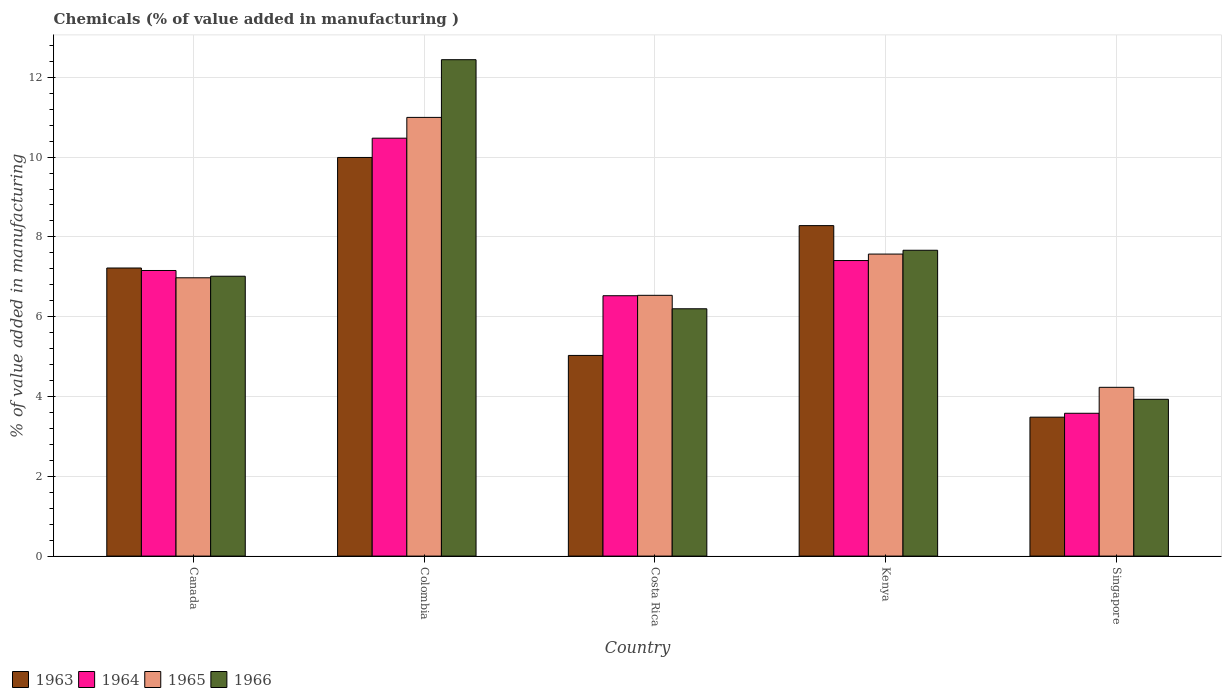How many bars are there on the 4th tick from the left?
Offer a very short reply. 4. What is the label of the 4th group of bars from the left?
Provide a succinct answer. Kenya. In how many cases, is the number of bars for a given country not equal to the number of legend labels?
Provide a succinct answer. 0. What is the value added in manufacturing chemicals in 1963 in Colombia?
Give a very brief answer. 9.99. Across all countries, what is the maximum value added in manufacturing chemicals in 1963?
Ensure brevity in your answer.  9.99. Across all countries, what is the minimum value added in manufacturing chemicals in 1964?
Make the answer very short. 3.58. In which country was the value added in manufacturing chemicals in 1964 maximum?
Make the answer very short. Colombia. In which country was the value added in manufacturing chemicals in 1965 minimum?
Make the answer very short. Singapore. What is the total value added in manufacturing chemicals in 1964 in the graph?
Your response must be concise. 35.15. What is the difference between the value added in manufacturing chemicals in 1965 in Costa Rica and that in Singapore?
Provide a short and direct response. 2.31. What is the difference between the value added in manufacturing chemicals in 1966 in Kenya and the value added in manufacturing chemicals in 1964 in Colombia?
Provide a succinct answer. -2.81. What is the average value added in manufacturing chemicals in 1964 per country?
Keep it short and to the point. 7.03. What is the difference between the value added in manufacturing chemicals of/in 1965 and value added in manufacturing chemicals of/in 1963 in Singapore?
Your answer should be compact. 0.75. What is the ratio of the value added in manufacturing chemicals in 1963 in Colombia to that in Kenya?
Keep it short and to the point. 1.21. Is the value added in manufacturing chemicals in 1965 in Costa Rica less than that in Kenya?
Provide a succinct answer. Yes. Is the difference between the value added in manufacturing chemicals in 1965 in Costa Rica and Singapore greater than the difference between the value added in manufacturing chemicals in 1963 in Costa Rica and Singapore?
Provide a short and direct response. Yes. What is the difference between the highest and the second highest value added in manufacturing chemicals in 1964?
Ensure brevity in your answer.  3.32. What is the difference between the highest and the lowest value added in manufacturing chemicals in 1964?
Provide a short and direct response. 6.89. In how many countries, is the value added in manufacturing chemicals in 1966 greater than the average value added in manufacturing chemicals in 1966 taken over all countries?
Offer a very short reply. 2. Is the sum of the value added in manufacturing chemicals in 1965 in Costa Rica and Kenya greater than the maximum value added in manufacturing chemicals in 1964 across all countries?
Ensure brevity in your answer.  Yes. Is it the case that in every country, the sum of the value added in manufacturing chemicals in 1966 and value added in manufacturing chemicals in 1965 is greater than the sum of value added in manufacturing chemicals in 1963 and value added in manufacturing chemicals in 1964?
Provide a succinct answer. No. What does the 1st bar from the left in Singapore represents?
Keep it short and to the point. 1963. How many bars are there?
Offer a terse response. 20. Are all the bars in the graph horizontal?
Your answer should be compact. No. What is the difference between two consecutive major ticks on the Y-axis?
Provide a succinct answer. 2. Does the graph contain any zero values?
Provide a short and direct response. No. Does the graph contain grids?
Ensure brevity in your answer.  Yes. How are the legend labels stacked?
Provide a short and direct response. Horizontal. What is the title of the graph?
Your answer should be very brief. Chemicals (% of value added in manufacturing ). What is the label or title of the X-axis?
Ensure brevity in your answer.  Country. What is the label or title of the Y-axis?
Make the answer very short. % of value added in manufacturing. What is the % of value added in manufacturing of 1963 in Canada?
Your answer should be compact. 7.22. What is the % of value added in manufacturing of 1964 in Canada?
Offer a terse response. 7.16. What is the % of value added in manufacturing of 1965 in Canada?
Keep it short and to the point. 6.98. What is the % of value added in manufacturing of 1966 in Canada?
Make the answer very short. 7.01. What is the % of value added in manufacturing of 1963 in Colombia?
Keep it short and to the point. 9.99. What is the % of value added in manufacturing of 1964 in Colombia?
Provide a short and direct response. 10.47. What is the % of value added in manufacturing in 1965 in Colombia?
Your response must be concise. 10.99. What is the % of value added in manufacturing of 1966 in Colombia?
Give a very brief answer. 12.44. What is the % of value added in manufacturing of 1963 in Costa Rica?
Keep it short and to the point. 5.03. What is the % of value added in manufacturing of 1964 in Costa Rica?
Offer a terse response. 6.53. What is the % of value added in manufacturing of 1965 in Costa Rica?
Make the answer very short. 6.54. What is the % of value added in manufacturing in 1966 in Costa Rica?
Give a very brief answer. 6.2. What is the % of value added in manufacturing of 1963 in Kenya?
Keep it short and to the point. 8.28. What is the % of value added in manufacturing of 1964 in Kenya?
Your answer should be compact. 7.41. What is the % of value added in manufacturing of 1965 in Kenya?
Offer a terse response. 7.57. What is the % of value added in manufacturing of 1966 in Kenya?
Offer a very short reply. 7.67. What is the % of value added in manufacturing of 1963 in Singapore?
Your response must be concise. 3.48. What is the % of value added in manufacturing in 1964 in Singapore?
Offer a terse response. 3.58. What is the % of value added in manufacturing of 1965 in Singapore?
Provide a succinct answer. 4.23. What is the % of value added in manufacturing in 1966 in Singapore?
Ensure brevity in your answer.  3.93. Across all countries, what is the maximum % of value added in manufacturing of 1963?
Make the answer very short. 9.99. Across all countries, what is the maximum % of value added in manufacturing of 1964?
Offer a very short reply. 10.47. Across all countries, what is the maximum % of value added in manufacturing of 1965?
Give a very brief answer. 10.99. Across all countries, what is the maximum % of value added in manufacturing in 1966?
Keep it short and to the point. 12.44. Across all countries, what is the minimum % of value added in manufacturing of 1963?
Your response must be concise. 3.48. Across all countries, what is the minimum % of value added in manufacturing in 1964?
Make the answer very short. 3.58. Across all countries, what is the minimum % of value added in manufacturing in 1965?
Offer a very short reply. 4.23. Across all countries, what is the minimum % of value added in manufacturing of 1966?
Offer a very short reply. 3.93. What is the total % of value added in manufacturing in 1963 in the graph?
Your answer should be compact. 34.01. What is the total % of value added in manufacturing of 1964 in the graph?
Ensure brevity in your answer.  35.15. What is the total % of value added in manufacturing of 1965 in the graph?
Your answer should be compact. 36.31. What is the total % of value added in manufacturing of 1966 in the graph?
Offer a terse response. 37.25. What is the difference between the % of value added in manufacturing of 1963 in Canada and that in Colombia?
Offer a very short reply. -2.77. What is the difference between the % of value added in manufacturing in 1964 in Canada and that in Colombia?
Make the answer very short. -3.32. What is the difference between the % of value added in manufacturing in 1965 in Canada and that in Colombia?
Offer a terse response. -4.02. What is the difference between the % of value added in manufacturing of 1966 in Canada and that in Colombia?
Provide a succinct answer. -5.43. What is the difference between the % of value added in manufacturing in 1963 in Canada and that in Costa Rica?
Make the answer very short. 2.19. What is the difference between the % of value added in manufacturing in 1964 in Canada and that in Costa Rica?
Offer a very short reply. 0.63. What is the difference between the % of value added in manufacturing in 1965 in Canada and that in Costa Rica?
Offer a very short reply. 0.44. What is the difference between the % of value added in manufacturing of 1966 in Canada and that in Costa Rica?
Offer a very short reply. 0.82. What is the difference between the % of value added in manufacturing in 1963 in Canada and that in Kenya?
Your response must be concise. -1.06. What is the difference between the % of value added in manufacturing of 1964 in Canada and that in Kenya?
Ensure brevity in your answer.  -0.25. What is the difference between the % of value added in manufacturing of 1965 in Canada and that in Kenya?
Ensure brevity in your answer.  -0.59. What is the difference between the % of value added in manufacturing in 1966 in Canada and that in Kenya?
Your answer should be very brief. -0.65. What is the difference between the % of value added in manufacturing in 1963 in Canada and that in Singapore?
Your answer should be very brief. 3.74. What is the difference between the % of value added in manufacturing in 1964 in Canada and that in Singapore?
Give a very brief answer. 3.58. What is the difference between the % of value added in manufacturing of 1965 in Canada and that in Singapore?
Your answer should be very brief. 2.75. What is the difference between the % of value added in manufacturing in 1966 in Canada and that in Singapore?
Provide a short and direct response. 3.08. What is the difference between the % of value added in manufacturing in 1963 in Colombia and that in Costa Rica?
Offer a very short reply. 4.96. What is the difference between the % of value added in manufacturing in 1964 in Colombia and that in Costa Rica?
Give a very brief answer. 3.95. What is the difference between the % of value added in manufacturing in 1965 in Colombia and that in Costa Rica?
Make the answer very short. 4.46. What is the difference between the % of value added in manufacturing of 1966 in Colombia and that in Costa Rica?
Make the answer very short. 6.24. What is the difference between the % of value added in manufacturing in 1963 in Colombia and that in Kenya?
Your answer should be very brief. 1.71. What is the difference between the % of value added in manufacturing of 1964 in Colombia and that in Kenya?
Your response must be concise. 3.07. What is the difference between the % of value added in manufacturing of 1965 in Colombia and that in Kenya?
Your response must be concise. 3.43. What is the difference between the % of value added in manufacturing in 1966 in Colombia and that in Kenya?
Your answer should be compact. 4.78. What is the difference between the % of value added in manufacturing in 1963 in Colombia and that in Singapore?
Make the answer very short. 6.51. What is the difference between the % of value added in manufacturing of 1964 in Colombia and that in Singapore?
Your answer should be very brief. 6.89. What is the difference between the % of value added in manufacturing in 1965 in Colombia and that in Singapore?
Your answer should be very brief. 6.76. What is the difference between the % of value added in manufacturing in 1966 in Colombia and that in Singapore?
Your answer should be compact. 8.51. What is the difference between the % of value added in manufacturing in 1963 in Costa Rica and that in Kenya?
Offer a very short reply. -3.25. What is the difference between the % of value added in manufacturing of 1964 in Costa Rica and that in Kenya?
Your response must be concise. -0.88. What is the difference between the % of value added in manufacturing in 1965 in Costa Rica and that in Kenya?
Give a very brief answer. -1.03. What is the difference between the % of value added in manufacturing in 1966 in Costa Rica and that in Kenya?
Your answer should be very brief. -1.47. What is the difference between the % of value added in manufacturing in 1963 in Costa Rica and that in Singapore?
Keep it short and to the point. 1.55. What is the difference between the % of value added in manufacturing of 1964 in Costa Rica and that in Singapore?
Your response must be concise. 2.95. What is the difference between the % of value added in manufacturing of 1965 in Costa Rica and that in Singapore?
Give a very brief answer. 2.31. What is the difference between the % of value added in manufacturing of 1966 in Costa Rica and that in Singapore?
Provide a succinct answer. 2.27. What is the difference between the % of value added in manufacturing in 1963 in Kenya and that in Singapore?
Offer a very short reply. 4.8. What is the difference between the % of value added in manufacturing in 1964 in Kenya and that in Singapore?
Your answer should be very brief. 3.83. What is the difference between the % of value added in manufacturing in 1965 in Kenya and that in Singapore?
Provide a succinct answer. 3.34. What is the difference between the % of value added in manufacturing of 1966 in Kenya and that in Singapore?
Your answer should be very brief. 3.74. What is the difference between the % of value added in manufacturing of 1963 in Canada and the % of value added in manufacturing of 1964 in Colombia?
Your answer should be compact. -3.25. What is the difference between the % of value added in manufacturing in 1963 in Canada and the % of value added in manufacturing in 1965 in Colombia?
Provide a succinct answer. -3.77. What is the difference between the % of value added in manufacturing in 1963 in Canada and the % of value added in manufacturing in 1966 in Colombia?
Provide a short and direct response. -5.22. What is the difference between the % of value added in manufacturing of 1964 in Canada and the % of value added in manufacturing of 1965 in Colombia?
Give a very brief answer. -3.84. What is the difference between the % of value added in manufacturing of 1964 in Canada and the % of value added in manufacturing of 1966 in Colombia?
Give a very brief answer. -5.28. What is the difference between the % of value added in manufacturing in 1965 in Canada and the % of value added in manufacturing in 1966 in Colombia?
Provide a short and direct response. -5.47. What is the difference between the % of value added in manufacturing of 1963 in Canada and the % of value added in manufacturing of 1964 in Costa Rica?
Provide a succinct answer. 0.69. What is the difference between the % of value added in manufacturing of 1963 in Canada and the % of value added in manufacturing of 1965 in Costa Rica?
Your answer should be very brief. 0.68. What is the difference between the % of value added in manufacturing in 1963 in Canada and the % of value added in manufacturing in 1966 in Costa Rica?
Make the answer very short. 1.02. What is the difference between the % of value added in manufacturing of 1964 in Canada and the % of value added in manufacturing of 1965 in Costa Rica?
Give a very brief answer. 0.62. What is the difference between the % of value added in manufacturing of 1964 in Canada and the % of value added in manufacturing of 1966 in Costa Rica?
Ensure brevity in your answer.  0.96. What is the difference between the % of value added in manufacturing in 1965 in Canada and the % of value added in manufacturing in 1966 in Costa Rica?
Ensure brevity in your answer.  0.78. What is the difference between the % of value added in manufacturing in 1963 in Canada and the % of value added in manufacturing in 1964 in Kenya?
Your answer should be very brief. -0.19. What is the difference between the % of value added in manufacturing of 1963 in Canada and the % of value added in manufacturing of 1965 in Kenya?
Keep it short and to the point. -0.35. What is the difference between the % of value added in manufacturing in 1963 in Canada and the % of value added in manufacturing in 1966 in Kenya?
Offer a very short reply. -0.44. What is the difference between the % of value added in manufacturing in 1964 in Canada and the % of value added in manufacturing in 1965 in Kenya?
Provide a succinct answer. -0.41. What is the difference between the % of value added in manufacturing of 1964 in Canada and the % of value added in manufacturing of 1966 in Kenya?
Your response must be concise. -0.51. What is the difference between the % of value added in manufacturing of 1965 in Canada and the % of value added in manufacturing of 1966 in Kenya?
Offer a terse response. -0.69. What is the difference between the % of value added in manufacturing in 1963 in Canada and the % of value added in manufacturing in 1964 in Singapore?
Make the answer very short. 3.64. What is the difference between the % of value added in manufacturing of 1963 in Canada and the % of value added in manufacturing of 1965 in Singapore?
Provide a succinct answer. 2.99. What is the difference between the % of value added in manufacturing in 1963 in Canada and the % of value added in manufacturing in 1966 in Singapore?
Provide a short and direct response. 3.29. What is the difference between the % of value added in manufacturing of 1964 in Canada and the % of value added in manufacturing of 1965 in Singapore?
Your response must be concise. 2.93. What is the difference between the % of value added in manufacturing in 1964 in Canada and the % of value added in manufacturing in 1966 in Singapore?
Ensure brevity in your answer.  3.23. What is the difference between the % of value added in manufacturing in 1965 in Canada and the % of value added in manufacturing in 1966 in Singapore?
Keep it short and to the point. 3.05. What is the difference between the % of value added in manufacturing of 1963 in Colombia and the % of value added in manufacturing of 1964 in Costa Rica?
Give a very brief answer. 3.47. What is the difference between the % of value added in manufacturing of 1963 in Colombia and the % of value added in manufacturing of 1965 in Costa Rica?
Your response must be concise. 3.46. What is the difference between the % of value added in manufacturing of 1963 in Colombia and the % of value added in manufacturing of 1966 in Costa Rica?
Your response must be concise. 3.79. What is the difference between the % of value added in manufacturing in 1964 in Colombia and the % of value added in manufacturing in 1965 in Costa Rica?
Make the answer very short. 3.94. What is the difference between the % of value added in manufacturing in 1964 in Colombia and the % of value added in manufacturing in 1966 in Costa Rica?
Offer a terse response. 4.28. What is the difference between the % of value added in manufacturing of 1965 in Colombia and the % of value added in manufacturing of 1966 in Costa Rica?
Provide a succinct answer. 4.8. What is the difference between the % of value added in manufacturing in 1963 in Colombia and the % of value added in manufacturing in 1964 in Kenya?
Your answer should be very brief. 2.58. What is the difference between the % of value added in manufacturing in 1963 in Colombia and the % of value added in manufacturing in 1965 in Kenya?
Provide a succinct answer. 2.42. What is the difference between the % of value added in manufacturing of 1963 in Colombia and the % of value added in manufacturing of 1966 in Kenya?
Offer a very short reply. 2.33. What is the difference between the % of value added in manufacturing in 1964 in Colombia and the % of value added in manufacturing in 1965 in Kenya?
Give a very brief answer. 2.9. What is the difference between the % of value added in manufacturing of 1964 in Colombia and the % of value added in manufacturing of 1966 in Kenya?
Your response must be concise. 2.81. What is the difference between the % of value added in manufacturing of 1965 in Colombia and the % of value added in manufacturing of 1966 in Kenya?
Your response must be concise. 3.33. What is the difference between the % of value added in manufacturing of 1963 in Colombia and the % of value added in manufacturing of 1964 in Singapore?
Offer a terse response. 6.41. What is the difference between the % of value added in manufacturing in 1963 in Colombia and the % of value added in manufacturing in 1965 in Singapore?
Your answer should be compact. 5.76. What is the difference between the % of value added in manufacturing of 1963 in Colombia and the % of value added in manufacturing of 1966 in Singapore?
Your response must be concise. 6.06. What is the difference between the % of value added in manufacturing in 1964 in Colombia and the % of value added in manufacturing in 1965 in Singapore?
Give a very brief answer. 6.24. What is the difference between the % of value added in manufacturing of 1964 in Colombia and the % of value added in manufacturing of 1966 in Singapore?
Your answer should be compact. 6.54. What is the difference between the % of value added in manufacturing of 1965 in Colombia and the % of value added in manufacturing of 1966 in Singapore?
Provide a succinct answer. 7.07. What is the difference between the % of value added in manufacturing in 1963 in Costa Rica and the % of value added in manufacturing in 1964 in Kenya?
Make the answer very short. -2.38. What is the difference between the % of value added in manufacturing of 1963 in Costa Rica and the % of value added in manufacturing of 1965 in Kenya?
Your response must be concise. -2.54. What is the difference between the % of value added in manufacturing of 1963 in Costa Rica and the % of value added in manufacturing of 1966 in Kenya?
Your answer should be very brief. -2.64. What is the difference between the % of value added in manufacturing in 1964 in Costa Rica and the % of value added in manufacturing in 1965 in Kenya?
Offer a very short reply. -1.04. What is the difference between the % of value added in manufacturing of 1964 in Costa Rica and the % of value added in manufacturing of 1966 in Kenya?
Provide a short and direct response. -1.14. What is the difference between the % of value added in manufacturing in 1965 in Costa Rica and the % of value added in manufacturing in 1966 in Kenya?
Keep it short and to the point. -1.13. What is the difference between the % of value added in manufacturing of 1963 in Costa Rica and the % of value added in manufacturing of 1964 in Singapore?
Ensure brevity in your answer.  1.45. What is the difference between the % of value added in manufacturing in 1963 in Costa Rica and the % of value added in manufacturing in 1965 in Singapore?
Offer a very short reply. 0.8. What is the difference between the % of value added in manufacturing of 1963 in Costa Rica and the % of value added in manufacturing of 1966 in Singapore?
Provide a succinct answer. 1.1. What is the difference between the % of value added in manufacturing in 1964 in Costa Rica and the % of value added in manufacturing in 1965 in Singapore?
Offer a terse response. 2.3. What is the difference between the % of value added in manufacturing of 1964 in Costa Rica and the % of value added in manufacturing of 1966 in Singapore?
Ensure brevity in your answer.  2.6. What is the difference between the % of value added in manufacturing in 1965 in Costa Rica and the % of value added in manufacturing in 1966 in Singapore?
Your response must be concise. 2.61. What is the difference between the % of value added in manufacturing in 1963 in Kenya and the % of value added in manufacturing in 1964 in Singapore?
Provide a succinct answer. 4.7. What is the difference between the % of value added in manufacturing of 1963 in Kenya and the % of value added in manufacturing of 1965 in Singapore?
Your answer should be compact. 4.05. What is the difference between the % of value added in manufacturing in 1963 in Kenya and the % of value added in manufacturing in 1966 in Singapore?
Your answer should be very brief. 4.35. What is the difference between the % of value added in manufacturing of 1964 in Kenya and the % of value added in manufacturing of 1965 in Singapore?
Offer a terse response. 3.18. What is the difference between the % of value added in manufacturing of 1964 in Kenya and the % of value added in manufacturing of 1966 in Singapore?
Give a very brief answer. 3.48. What is the difference between the % of value added in manufacturing in 1965 in Kenya and the % of value added in manufacturing in 1966 in Singapore?
Offer a very short reply. 3.64. What is the average % of value added in manufacturing of 1963 per country?
Provide a short and direct response. 6.8. What is the average % of value added in manufacturing of 1964 per country?
Offer a terse response. 7.03. What is the average % of value added in manufacturing of 1965 per country?
Provide a short and direct response. 7.26. What is the average % of value added in manufacturing in 1966 per country?
Ensure brevity in your answer.  7.45. What is the difference between the % of value added in manufacturing of 1963 and % of value added in manufacturing of 1964 in Canada?
Offer a very short reply. 0.06. What is the difference between the % of value added in manufacturing of 1963 and % of value added in manufacturing of 1965 in Canada?
Your response must be concise. 0.25. What is the difference between the % of value added in manufacturing of 1963 and % of value added in manufacturing of 1966 in Canada?
Offer a very short reply. 0.21. What is the difference between the % of value added in manufacturing of 1964 and % of value added in manufacturing of 1965 in Canada?
Make the answer very short. 0.18. What is the difference between the % of value added in manufacturing of 1964 and % of value added in manufacturing of 1966 in Canada?
Provide a succinct answer. 0.14. What is the difference between the % of value added in manufacturing of 1965 and % of value added in manufacturing of 1966 in Canada?
Offer a terse response. -0.04. What is the difference between the % of value added in manufacturing in 1963 and % of value added in manufacturing in 1964 in Colombia?
Provide a succinct answer. -0.48. What is the difference between the % of value added in manufacturing in 1963 and % of value added in manufacturing in 1965 in Colombia?
Keep it short and to the point. -1. What is the difference between the % of value added in manufacturing in 1963 and % of value added in manufacturing in 1966 in Colombia?
Offer a very short reply. -2.45. What is the difference between the % of value added in manufacturing of 1964 and % of value added in manufacturing of 1965 in Colombia?
Your answer should be very brief. -0.52. What is the difference between the % of value added in manufacturing of 1964 and % of value added in manufacturing of 1966 in Colombia?
Make the answer very short. -1.97. What is the difference between the % of value added in manufacturing of 1965 and % of value added in manufacturing of 1966 in Colombia?
Provide a succinct answer. -1.45. What is the difference between the % of value added in manufacturing in 1963 and % of value added in manufacturing in 1964 in Costa Rica?
Provide a succinct answer. -1.5. What is the difference between the % of value added in manufacturing of 1963 and % of value added in manufacturing of 1965 in Costa Rica?
Offer a terse response. -1.51. What is the difference between the % of value added in manufacturing in 1963 and % of value added in manufacturing in 1966 in Costa Rica?
Keep it short and to the point. -1.17. What is the difference between the % of value added in manufacturing of 1964 and % of value added in manufacturing of 1965 in Costa Rica?
Keep it short and to the point. -0.01. What is the difference between the % of value added in manufacturing of 1964 and % of value added in manufacturing of 1966 in Costa Rica?
Your answer should be compact. 0.33. What is the difference between the % of value added in manufacturing in 1965 and % of value added in manufacturing in 1966 in Costa Rica?
Make the answer very short. 0.34. What is the difference between the % of value added in manufacturing of 1963 and % of value added in manufacturing of 1964 in Kenya?
Keep it short and to the point. 0.87. What is the difference between the % of value added in manufacturing in 1963 and % of value added in manufacturing in 1965 in Kenya?
Ensure brevity in your answer.  0.71. What is the difference between the % of value added in manufacturing of 1963 and % of value added in manufacturing of 1966 in Kenya?
Your response must be concise. 0.62. What is the difference between the % of value added in manufacturing of 1964 and % of value added in manufacturing of 1965 in Kenya?
Your response must be concise. -0.16. What is the difference between the % of value added in manufacturing of 1964 and % of value added in manufacturing of 1966 in Kenya?
Offer a very short reply. -0.26. What is the difference between the % of value added in manufacturing in 1965 and % of value added in manufacturing in 1966 in Kenya?
Offer a terse response. -0.1. What is the difference between the % of value added in manufacturing of 1963 and % of value added in manufacturing of 1964 in Singapore?
Ensure brevity in your answer.  -0.1. What is the difference between the % of value added in manufacturing in 1963 and % of value added in manufacturing in 1965 in Singapore?
Your answer should be very brief. -0.75. What is the difference between the % of value added in manufacturing in 1963 and % of value added in manufacturing in 1966 in Singapore?
Provide a succinct answer. -0.45. What is the difference between the % of value added in manufacturing of 1964 and % of value added in manufacturing of 1965 in Singapore?
Your answer should be very brief. -0.65. What is the difference between the % of value added in manufacturing in 1964 and % of value added in manufacturing in 1966 in Singapore?
Your answer should be compact. -0.35. What is the difference between the % of value added in manufacturing of 1965 and % of value added in manufacturing of 1966 in Singapore?
Give a very brief answer. 0.3. What is the ratio of the % of value added in manufacturing of 1963 in Canada to that in Colombia?
Make the answer very short. 0.72. What is the ratio of the % of value added in manufacturing in 1964 in Canada to that in Colombia?
Provide a succinct answer. 0.68. What is the ratio of the % of value added in manufacturing in 1965 in Canada to that in Colombia?
Your answer should be very brief. 0.63. What is the ratio of the % of value added in manufacturing in 1966 in Canada to that in Colombia?
Your answer should be compact. 0.56. What is the ratio of the % of value added in manufacturing in 1963 in Canada to that in Costa Rica?
Keep it short and to the point. 1.44. What is the ratio of the % of value added in manufacturing in 1964 in Canada to that in Costa Rica?
Your answer should be very brief. 1.1. What is the ratio of the % of value added in manufacturing of 1965 in Canada to that in Costa Rica?
Give a very brief answer. 1.07. What is the ratio of the % of value added in manufacturing of 1966 in Canada to that in Costa Rica?
Your answer should be compact. 1.13. What is the ratio of the % of value added in manufacturing in 1963 in Canada to that in Kenya?
Make the answer very short. 0.87. What is the ratio of the % of value added in manufacturing in 1964 in Canada to that in Kenya?
Offer a very short reply. 0.97. What is the ratio of the % of value added in manufacturing of 1965 in Canada to that in Kenya?
Offer a terse response. 0.92. What is the ratio of the % of value added in manufacturing in 1966 in Canada to that in Kenya?
Ensure brevity in your answer.  0.92. What is the ratio of the % of value added in manufacturing in 1963 in Canada to that in Singapore?
Keep it short and to the point. 2.07. What is the ratio of the % of value added in manufacturing of 1964 in Canada to that in Singapore?
Offer a terse response. 2. What is the ratio of the % of value added in manufacturing of 1965 in Canada to that in Singapore?
Keep it short and to the point. 1.65. What is the ratio of the % of value added in manufacturing in 1966 in Canada to that in Singapore?
Give a very brief answer. 1.78. What is the ratio of the % of value added in manufacturing in 1963 in Colombia to that in Costa Rica?
Your answer should be very brief. 1.99. What is the ratio of the % of value added in manufacturing in 1964 in Colombia to that in Costa Rica?
Keep it short and to the point. 1.61. What is the ratio of the % of value added in manufacturing in 1965 in Colombia to that in Costa Rica?
Keep it short and to the point. 1.68. What is the ratio of the % of value added in manufacturing in 1966 in Colombia to that in Costa Rica?
Your answer should be compact. 2.01. What is the ratio of the % of value added in manufacturing in 1963 in Colombia to that in Kenya?
Keep it short and to the point. 1.21. What is the ratio of the % of value added in manufacturing in 1964 in Colombia to that in Kenya?
Ensure brevity in your answer.  1.41. What is the ratio of the % of value added in manufacturing of 1965 in Colombia to that in Kenya?
Make the answer very short. 1.45. What is the ratio of the % of value added in manufacturing in 1966 in Colombia to that in Kenya?
Keep it short and to the point. 1.62. What is the ratio of the % of value added in manufacturing in 1963 in Colombia to that in Singapore?
Provide a short and direct response. 2.87. What is the ratio of the % of value added in manufacturing in 1964 in Colombia to that in Singapore?
Make the answer very short. 2.93. What is the ratio of the % of value added in manufacturing in 1965 in Colombia to that in Singapore?
Offer a terse response. 2.6. What is the ratio of the % of value added in manufacturing in 1966 in Colombia to that in Singapore?
Offer a terse response. 3.17. What is the ratio of the % of value added in manufacturing of 1963 in Costa Rica to that in Kenya?
Your answer should be compact. 0.61. What is the ratio of the % of value added in manufacturing in 1964 in Costa Rica to that in Kenya?
Offer a terse response. 0.88. What is the ratio of the % of value added in manufacturing of 1965 in Costa Rica to that in Kenya?
Provide a succinct answer. 0.86. What is the ratio of the % of value added in manufacturing in 1966 in Costa Rica to that in Kenya?
Your answer should be very brief. 0.81. What is the ratio of the % of value added in manufacturing of 1963 in Costa Rica to that in Singapore?
Offer a terse response. 1.44. What is the ratio of the % of value added in manufacturing in 1964 in Costa Rica to that in Singapore?
Give a very brief answer. 1.82. What is the ratio of the % of value added in manufacturing in 1965 in Costa Rica to that in Singapore?
Offer a terse response. 1.55. What is the ratio of the % of value added in manufacturing in 1966 in Costa Rica to that in Singapore?
Your response must be concise. 1.58. What is the ratio of the % of value added in manufacturing of 1963 in Kenya to that in Singapore?
Your answer should be compact. 2.38. What is the ratio of the % of value added in manufacturing in 1964 in Kenya to that in Singapore?
Ensure brevity in your answer.  2.07. What is the ratio of the % of value added in manufacturing in 1965 in Kenya to that in Singapore?
Your answer should be compact. 1.79. What is the ratio of the % of value added in manufacturing in 1966 in Kenya to that in Singapore?
Your response must be concise. 1.95. What is the difference between the highest and the second highest % of value added in manufacturing in 1963?
Make the answer very short. 1.71. What is the difference between the highest and the second highest % of value added in manufacturing in 1964?
Ensure brevity in your answer.  3.07. What is the difference between the highest and the second highest % of value added in manufacturing of 1965?
Your response must be concise. 3.43. What is the difference between the highest and the second highest % of value added in manufacturing of 1966?
Provide a succinct answer. 4.78. What is the difference between the highest and the lowest % of value added in manufacturing in 1963?
Provide a succinct answer. 6.51. What is the difference between the highest and the lowest % of value added in manufacturing of 1964?
Provide a succinct answer. 6.89. What is the difference between the highest and the lowest % of value added in manufacturing of 1965?
Offer a very short reply. 6.76. What is the difference between the highest and the lowest % of value added in manufacturing in 1966?
Your answer should be very brief. 8.51. 